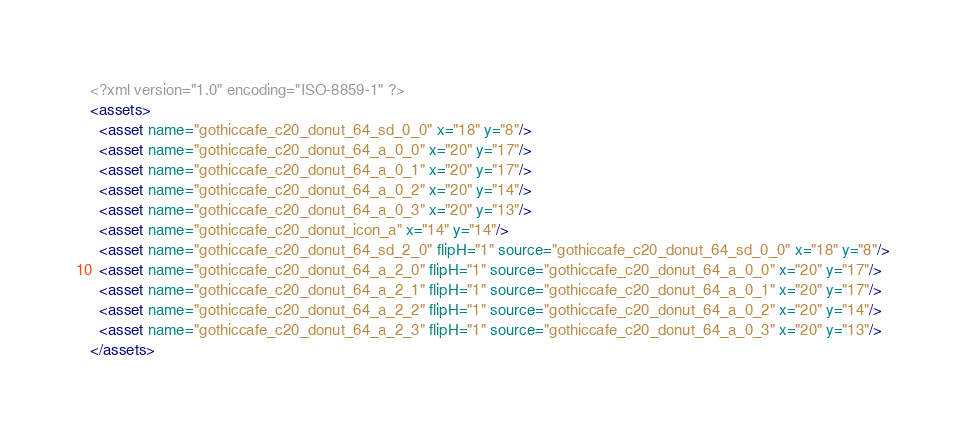<code> <loc_0><loc_0><loc_500><loc_500><_XML_><?xml version="1.0" encoding="ISO-8859-1" ?><assets>
  <asset name="gothiccafe_c20_donut_64_sd_0_0" x="18" y="8"/>
  <asset name="gothiccafe_c20_donut_64_a_0_0" x="20" y="17"/>
  <asset name="gothiccafe_c20_donut_64_a_0_1" x="20" y="17"/>
  <asset name="gothiccafe_c20_donut_64_a_0_2" x="20" y="14"/>
  <asset name="gothiccafe_c20_donut_64_a_0_3" x="20" y="13"/>
  <asset name="gothiccafe_c20_donut_icon_a" x="14" y="14"/>
  <asset name="gothiccafe_c20_donut_64_sd_2_0" flipH="1" source="gothiccafe_c20_donut_64_sd_0_0" x="18" y="8"/>
  <asset name="gothiccafe_c20_donut_64_a_2_0" flipH="1" source="gothiccafe_c20_donut_64_a_0_0" x="20" y="17"/>
  <asset name="gothiccafe_c20_donut_64_a_2_1" flipH="1" source="gothiccafe_c20_donut_64_a_0_1" x="20" y="17"/>
  <asset name="gothiccafe_c20_donut_64_a_2_2" flipH="1" source="gothiccafe_c20_donut_64_a_0_2" x="20" y="14"/>
  <asset name="gothiccafe_c20_donut_64_a_2_3" flipH="1" source="gothiccafe_c20_donut_64_a_0_3" x="20" y="13"/>
</assets></code> 